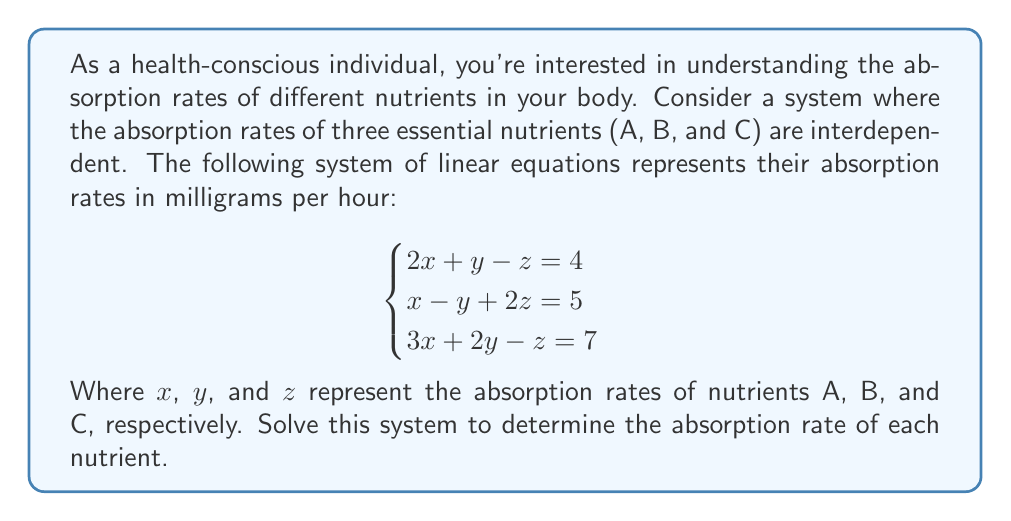Give your solution to this math problem. To solve this system of linear equations, we'll use the Gaussian elimination method:

1) First, write the augmented matrix:

   $$\begin{bmatrix}
   2 & 1 & -1 & 4 \\
   1 & -1 & 2 & 5 \\
   3 & 2 & -1 & 7
   \end{bmatrix}$$

2) Multiply the first row by -1/2 and add it to the second row:

   $$\begin{bmatrix}
   2 & 1 & -1 & 4 \\
   0 & -3/2 & 5/2 & 3 \\
   3 & 2 & -1 & 7
   \end{bmatrix}$$

3) Multiply the first row by -3/2 and add it to the third row:

   $$\begin{bmatrix}
   2 & 1 & -1 & 4 \\
   0 & -3/2 & 5/2 & 3 \\
   0 & 1/2 & 1/2 & 1
   \end{bmatrix}$$

4) Multiply the second row by -1/3 and add it to the third row:

   $$\begin{bmatrix}
   2 & 1 & -1 & 4 \\
   0 & -3/2 & 5/2 & 3 \\
   0 & 0 & -5/6 & -1
   \end{bmatrix}$$

5) Now we have an upper triangular matrix. We can solve for z:

   $-5/6z = -1$
   $z = 6/5 = 1.2$

6) Substitute this value in the second equation:

   $-3/2y + 5/2(1.2) = 3$
   $-3/2y + 3 = 3$
   $-3/2y = 0$
   $y = 0$

7) Finally, substitute these values in the first equation:

   $2x + 0 - 1.2 = 4$
   $2x = 5.2$
   $x = 2.6$

Therefore, the absorption rates are:
x = 2.6 mg/hour (Nutrient A)
y = 0 mg/hour (Nutrient B)
z = 1.2 mg/hour (Nutrient C)
Answer: The absorption rates are:
Nutrient A: 2.6 mg/hour
Nutrient B: 0 mg/hour
Nutrient C: 1.2 mg/hour 